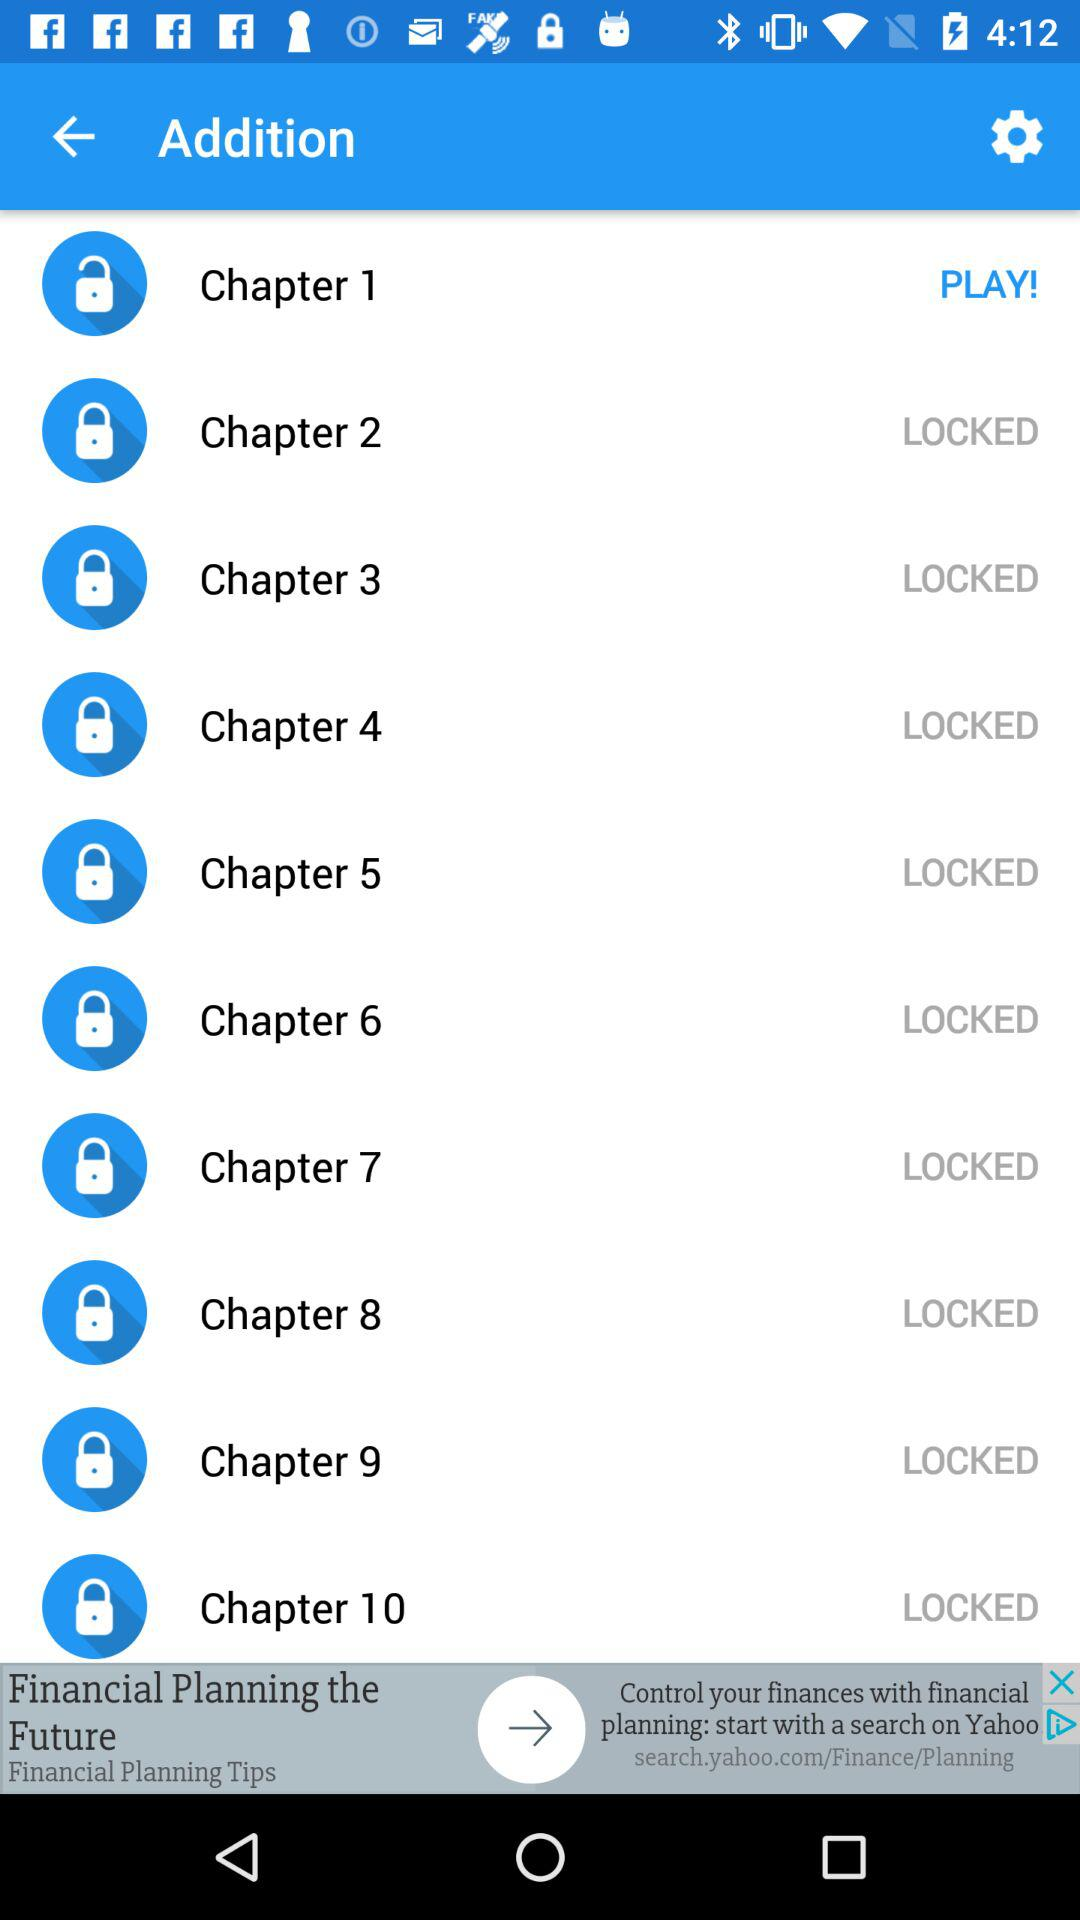How many chapters are unlocked?
Answer the question using a single word or phrase. 1 